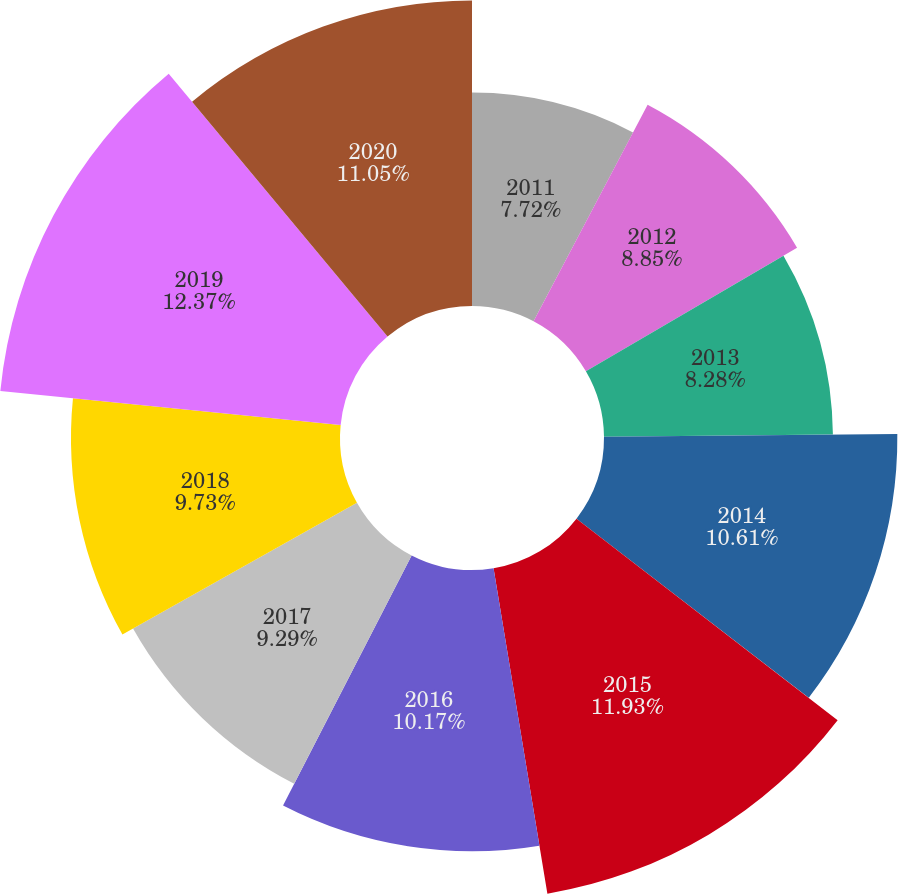Convert chart to OTSL. <chart><loc_0><loc_0><loc_500><loc_500><pie_chart><fcel>2011<fcel>2012<fcel>2013<fcel>2014<fcel>2015<fcel>2016<fcel>2017<fcel>2018<fcel>2019<fcel>2020<nl><fcel>7.72%<fcel>8.85%<fcel>8.28%<fcel>10.61%<fcel>11.93%<fcel>10.17%<fcel>9.29%<fcel>9.73%<fcel>12.37%<fcel>11.05%<nl></chart> 